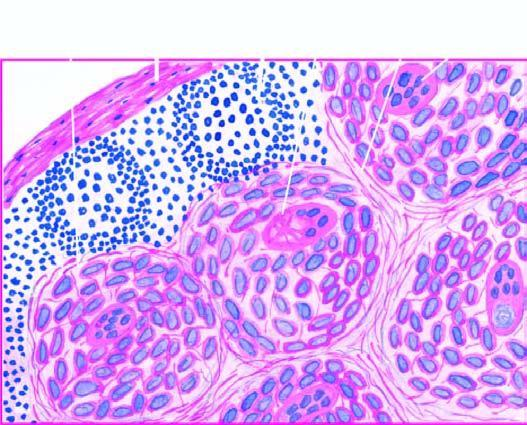re there non-caseating epithelioid cell granulomas which have paucity of lymphocytes?
Answer the question using a single word or phrase. Yes 